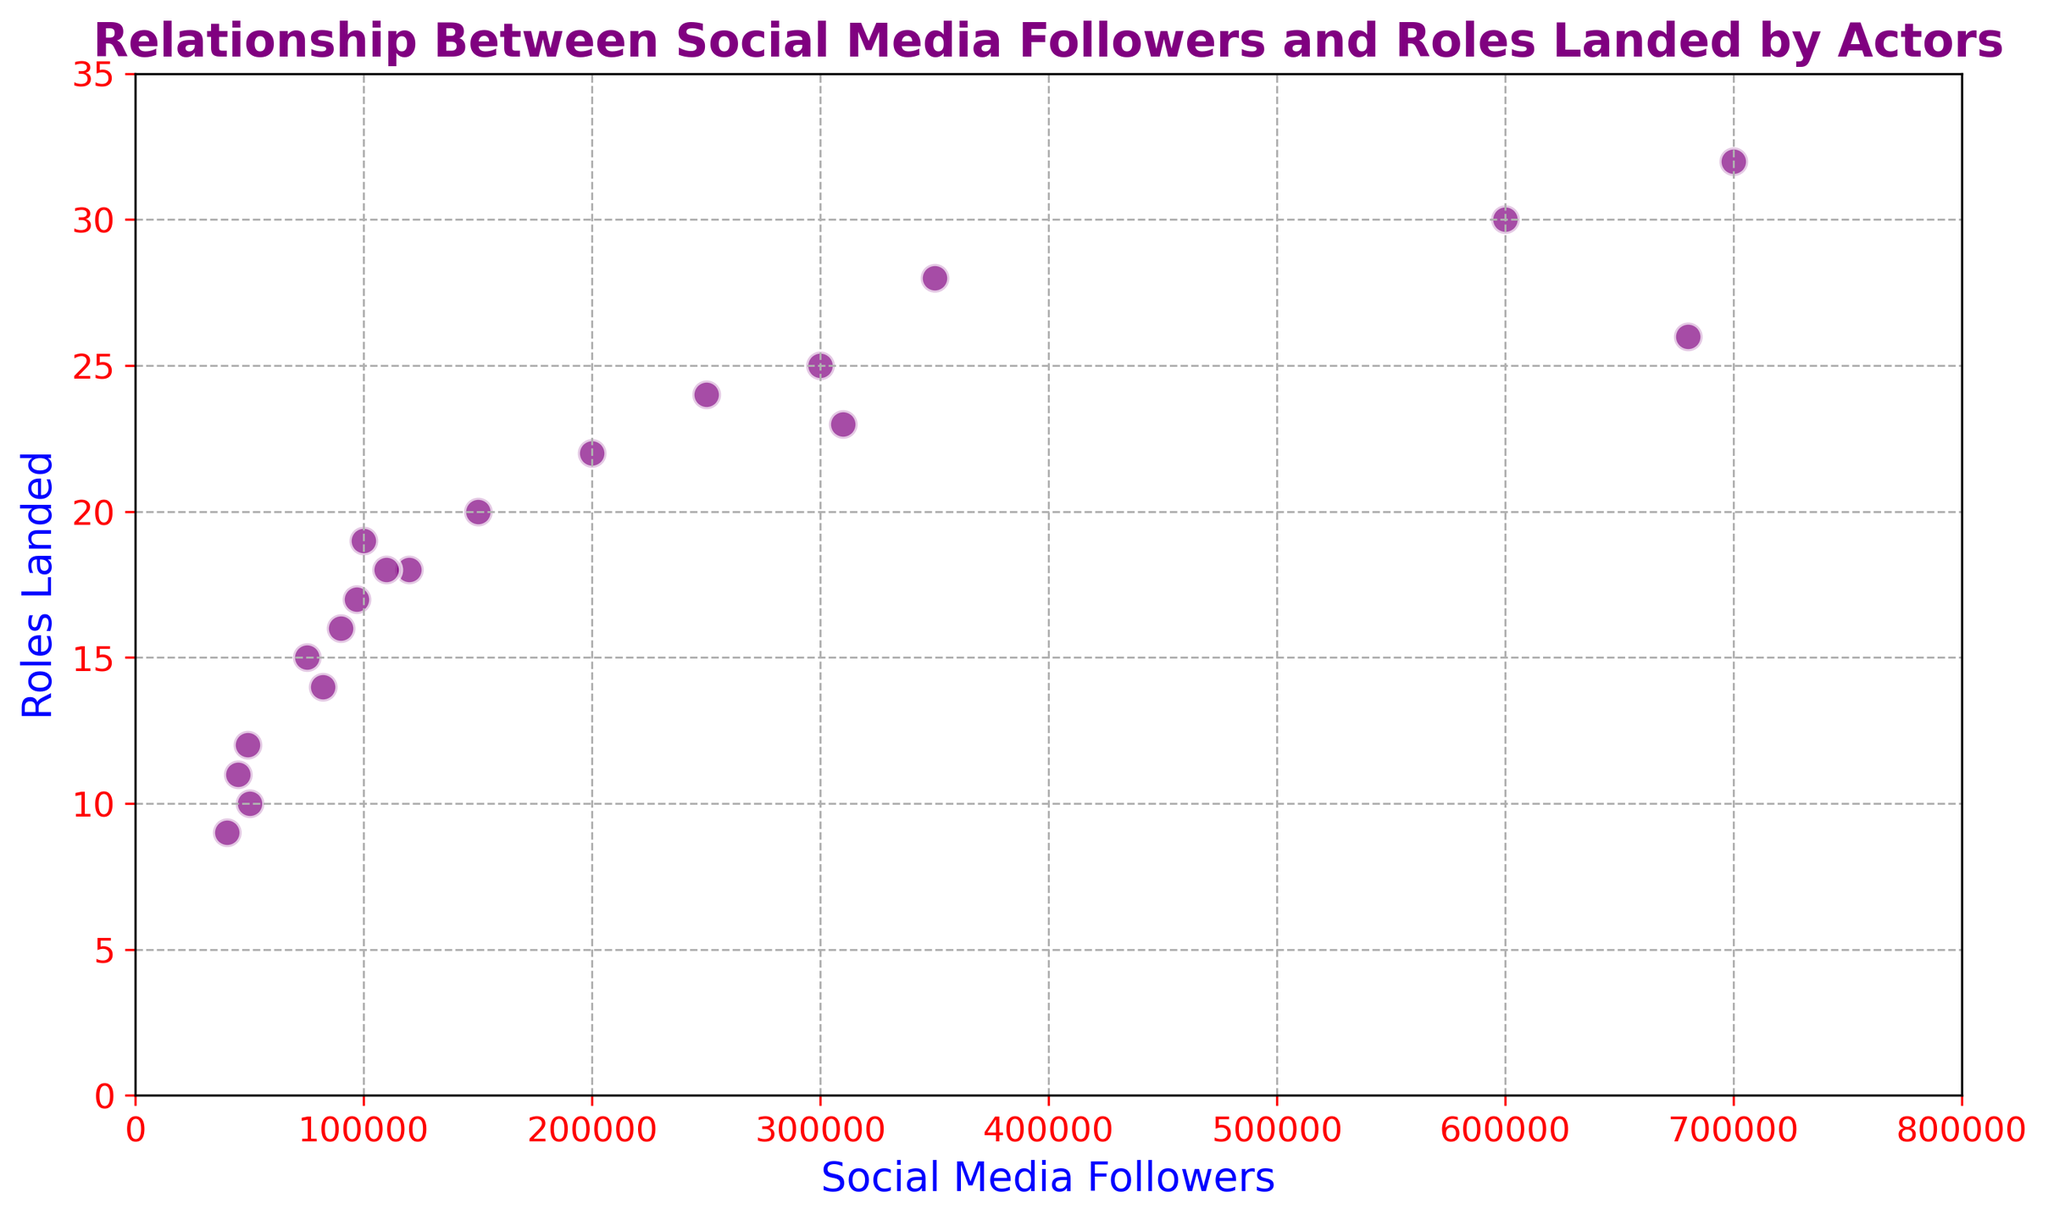How many roles did the actor with the most social media followers land? The actor with the most social media followers has 700,000 followers. From the plot, this actor landed 32 roles.
Answer: 32 Which actor has the fewest roles landed, and how many social media followers do they have? The actor with the fewest roles landed has 9 roles. From the plot, this actor has 40,000 social media followers.
Answer: 40,000 Is there a correlation between the number of social media followers and the number of roles landed? From the scatter plot, there appears to be a positive correlation; generally, as the number of social media followers increases, the number of roles landed tends to increase as well.
Answer: Yes, there appears to be a positive correlation What is the average number of roles landed by actors with more than 300,000 social media followers? Identify the actors with more than 300,000 followers: 300,000 (25), 350,000 (28), 600,000 (30), 700,000 (32), 680,000 (26), 310,000 (23). Sum their roles: 25 + 28 + 30 + 32 + 26 + 23 = 164. There are 6 actors, so the average is 164 / 6.
Answer: 27.33 How many actors have more than 100,000 social media followers and have landed at least 20 roles? Identify the actors with more than 100,000 followers and at least 20 roles: 300,000 (25), 200,000 (22), 350,000 (28), 600,000 (30), 700,000 (32), 680,000 (26), 310,000 (23). Count these actors; there are 7.
Answer: 7 